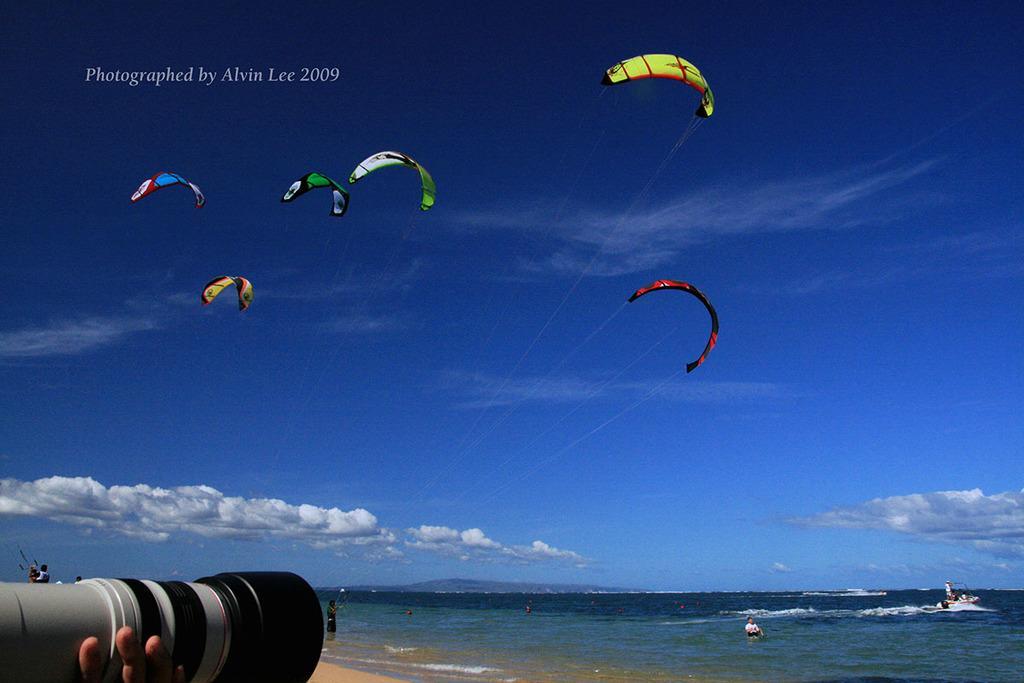Please provide a concise description of this image. In this image there are persons kitesurfing in the center and the sky is cloudy. In the front there is a camera which is holded by a person. 